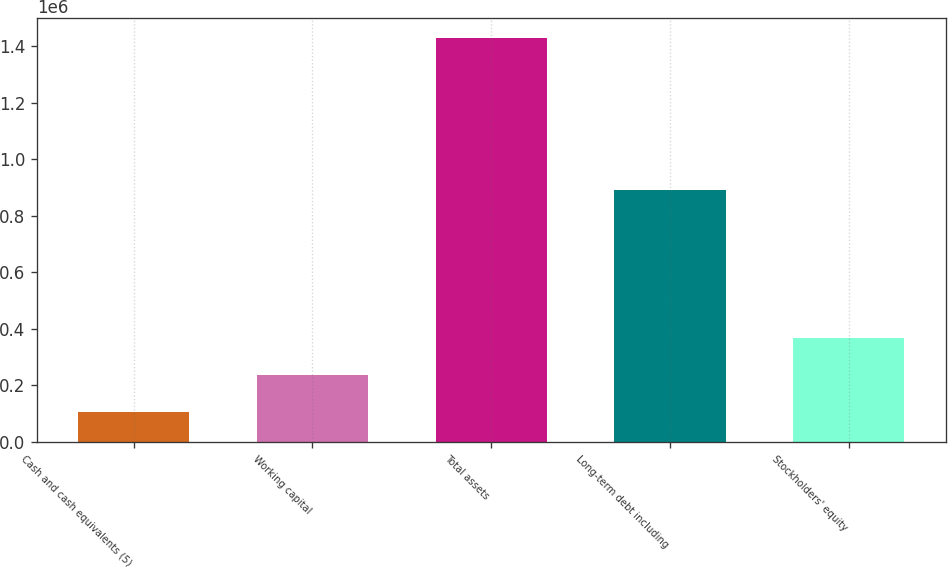<chart> <loc_0><loc_0><loc_500><loc_500><bar_chart><fcel>Cash and cash equivalents (5)<fcel>Working capital<fcel>Total assets<fcel>Long-term debt including<fcel>Stockholders' equity<nl><fcel>104221<fcel>236574<fcel>1.42775e+06<fcel>889846<fcel>368926<nl></chart> 